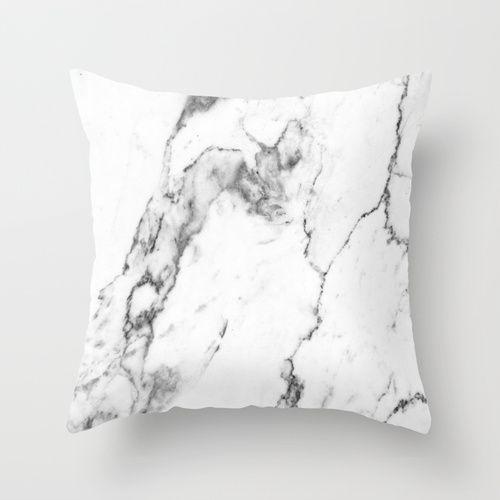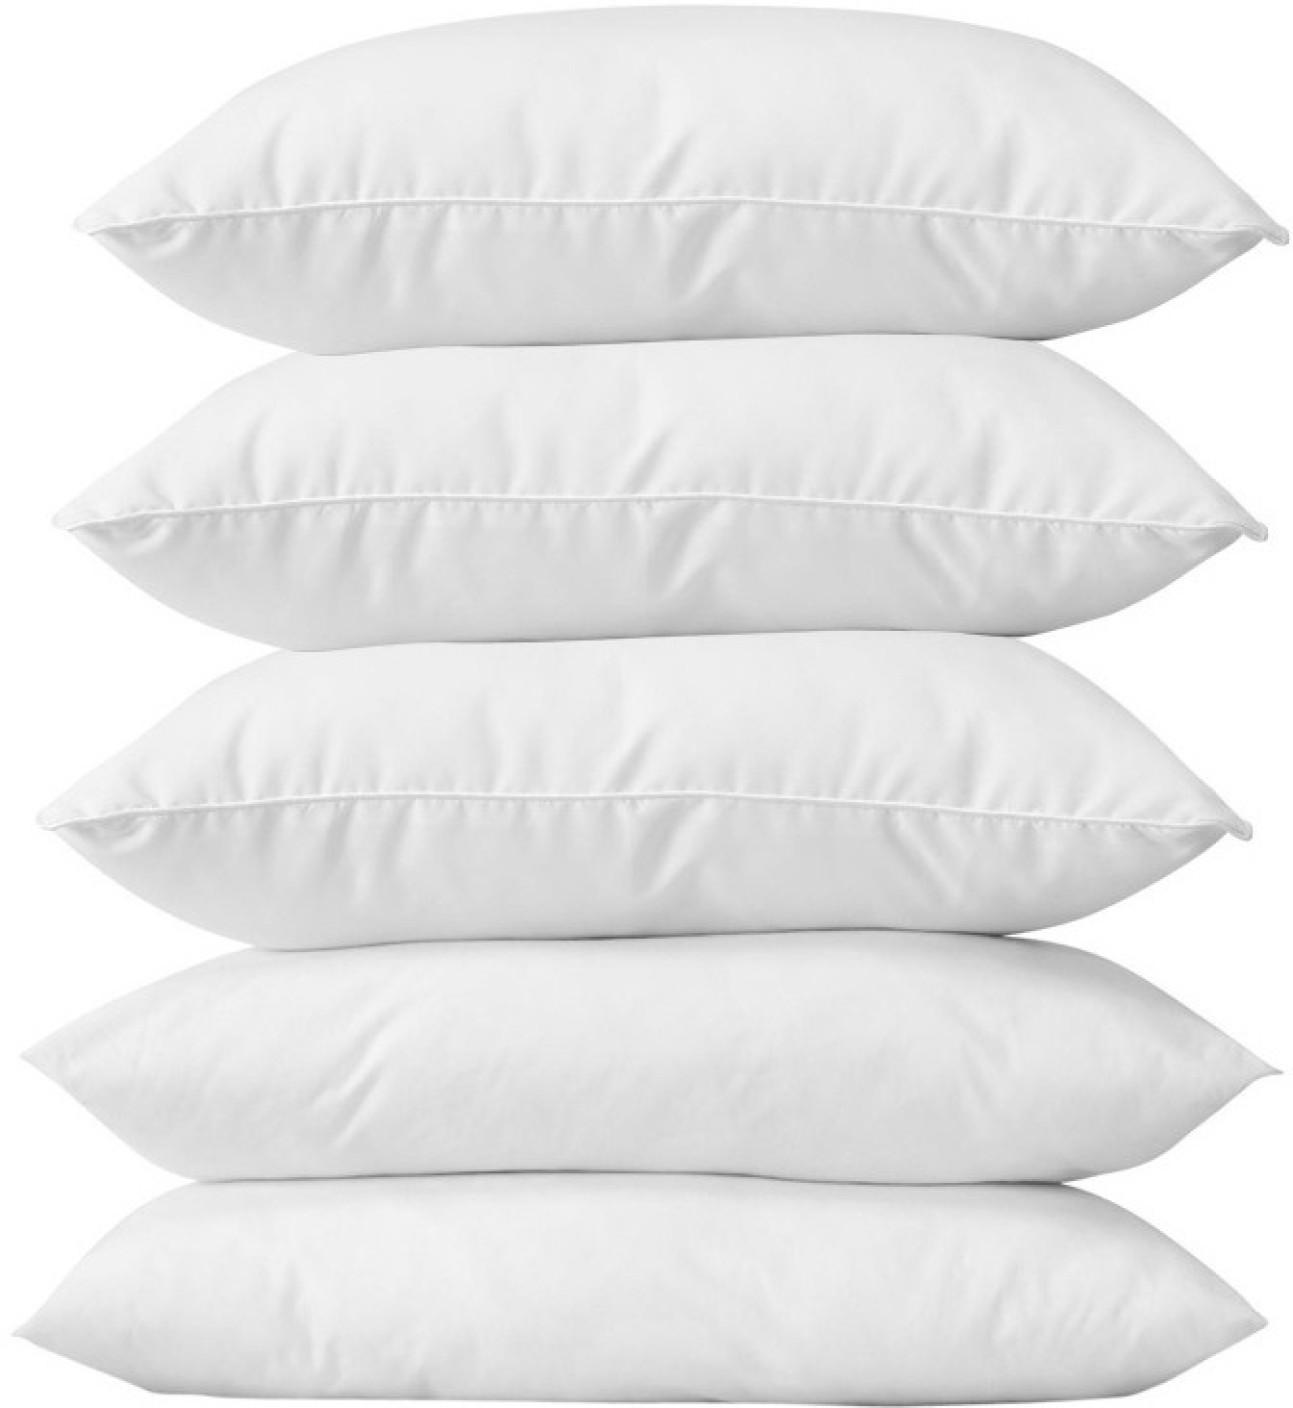The first image is the image on the left, the second image is the image on the right. Examine the images to the left and right. Is the description "No less than four white pillows are stacked directly on top of one another" accurate? Answer yes or no. Yes. The first image is the image on the left, the second image is the image on the right. For the images displayed, is the sentence "multiple pillows are stacked on top of each other" factually correct? Answer yes or no. Yes. 